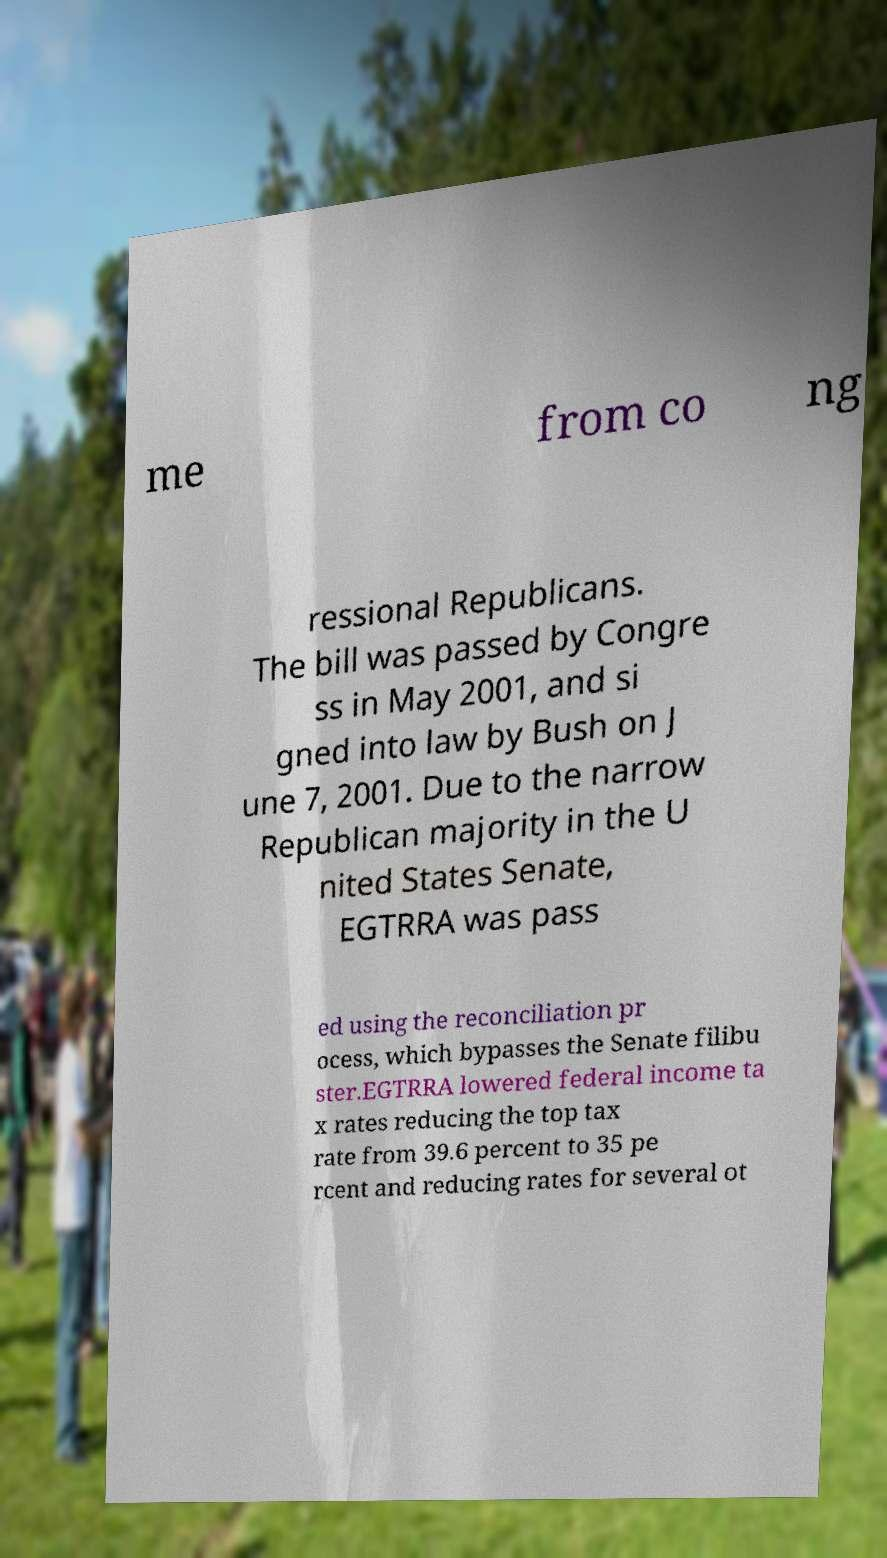There's text embedded in this image that I need extracted. Can you transcribe it verbatim? me from co ng ressional Republicans. The bill was passed by Congre ss in May 2001, and si gned into law by Bush on J une 7, 2001. Due to the narrow Republican majority in the U nited States Senate, EGTRRA was pass ed using the reconciliation pr ocess, which bypasses the Senate filibu ster.EGTRRA lowered federal income ta x rates reducing the top tax rate from 39.6 percent to 35 pe rcent and reducing rates for several ot 